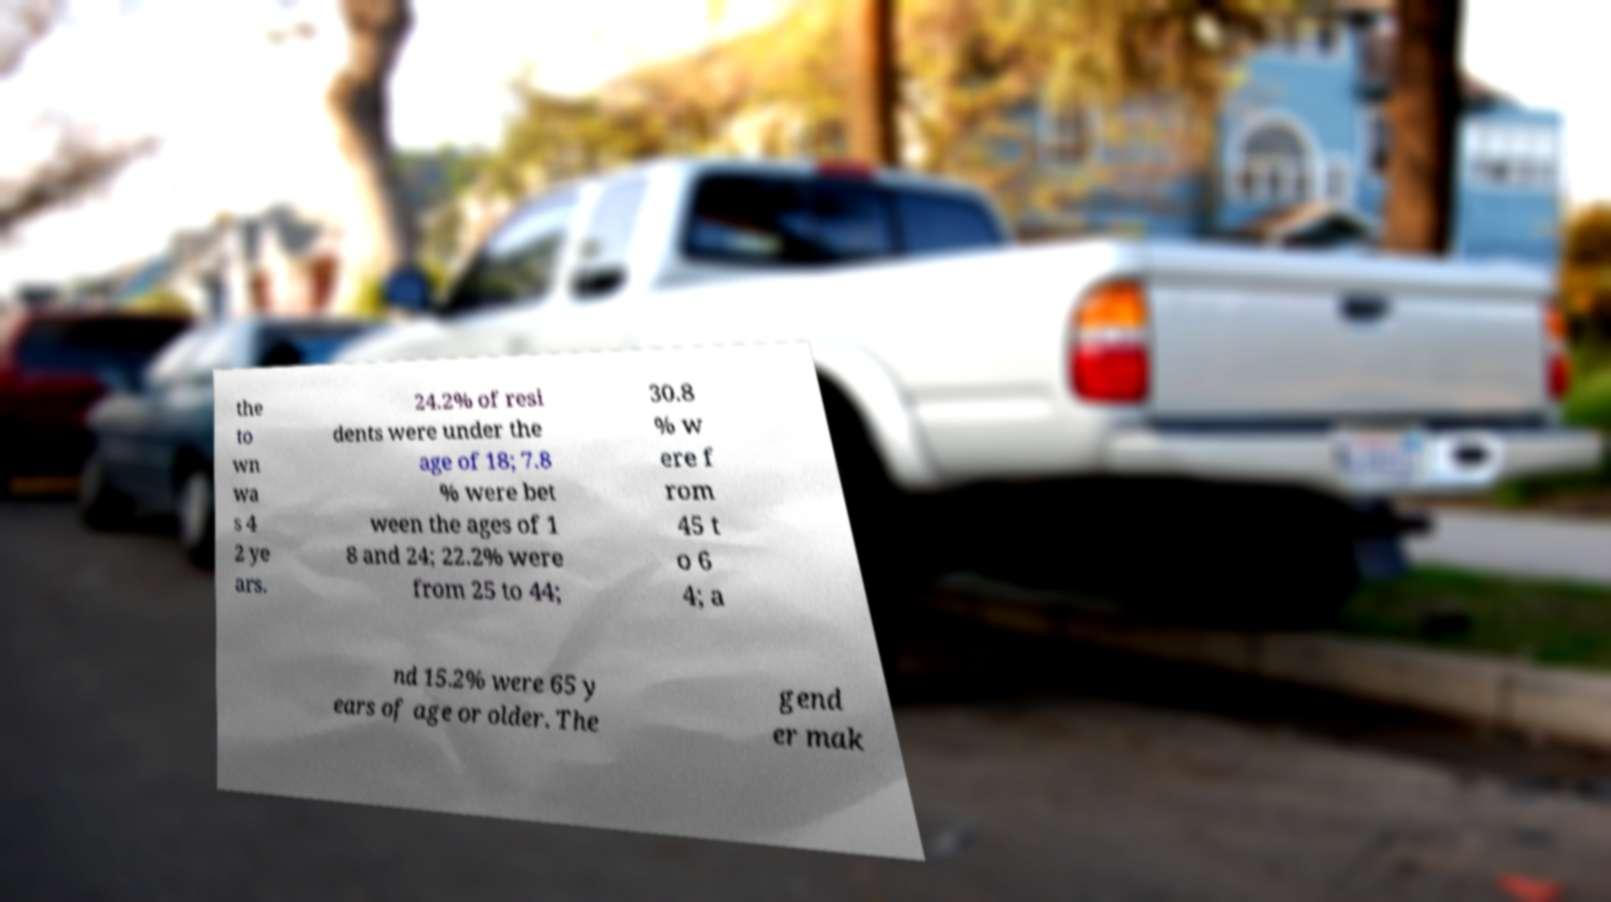What messages or text are displayed in this image? I need them in a readable, typed format. the to wn wa s 4 2 ye ars. 24.2% of resi dents were under the age of 18; 7.8 % were bet ween the ages of 1 8 and 24; 22.2% were from 25 to 44; 30.8 % w ere f rom 45 t o 6 4; a nd 15.2% were 65 y ears of age or older. The gend er mak 